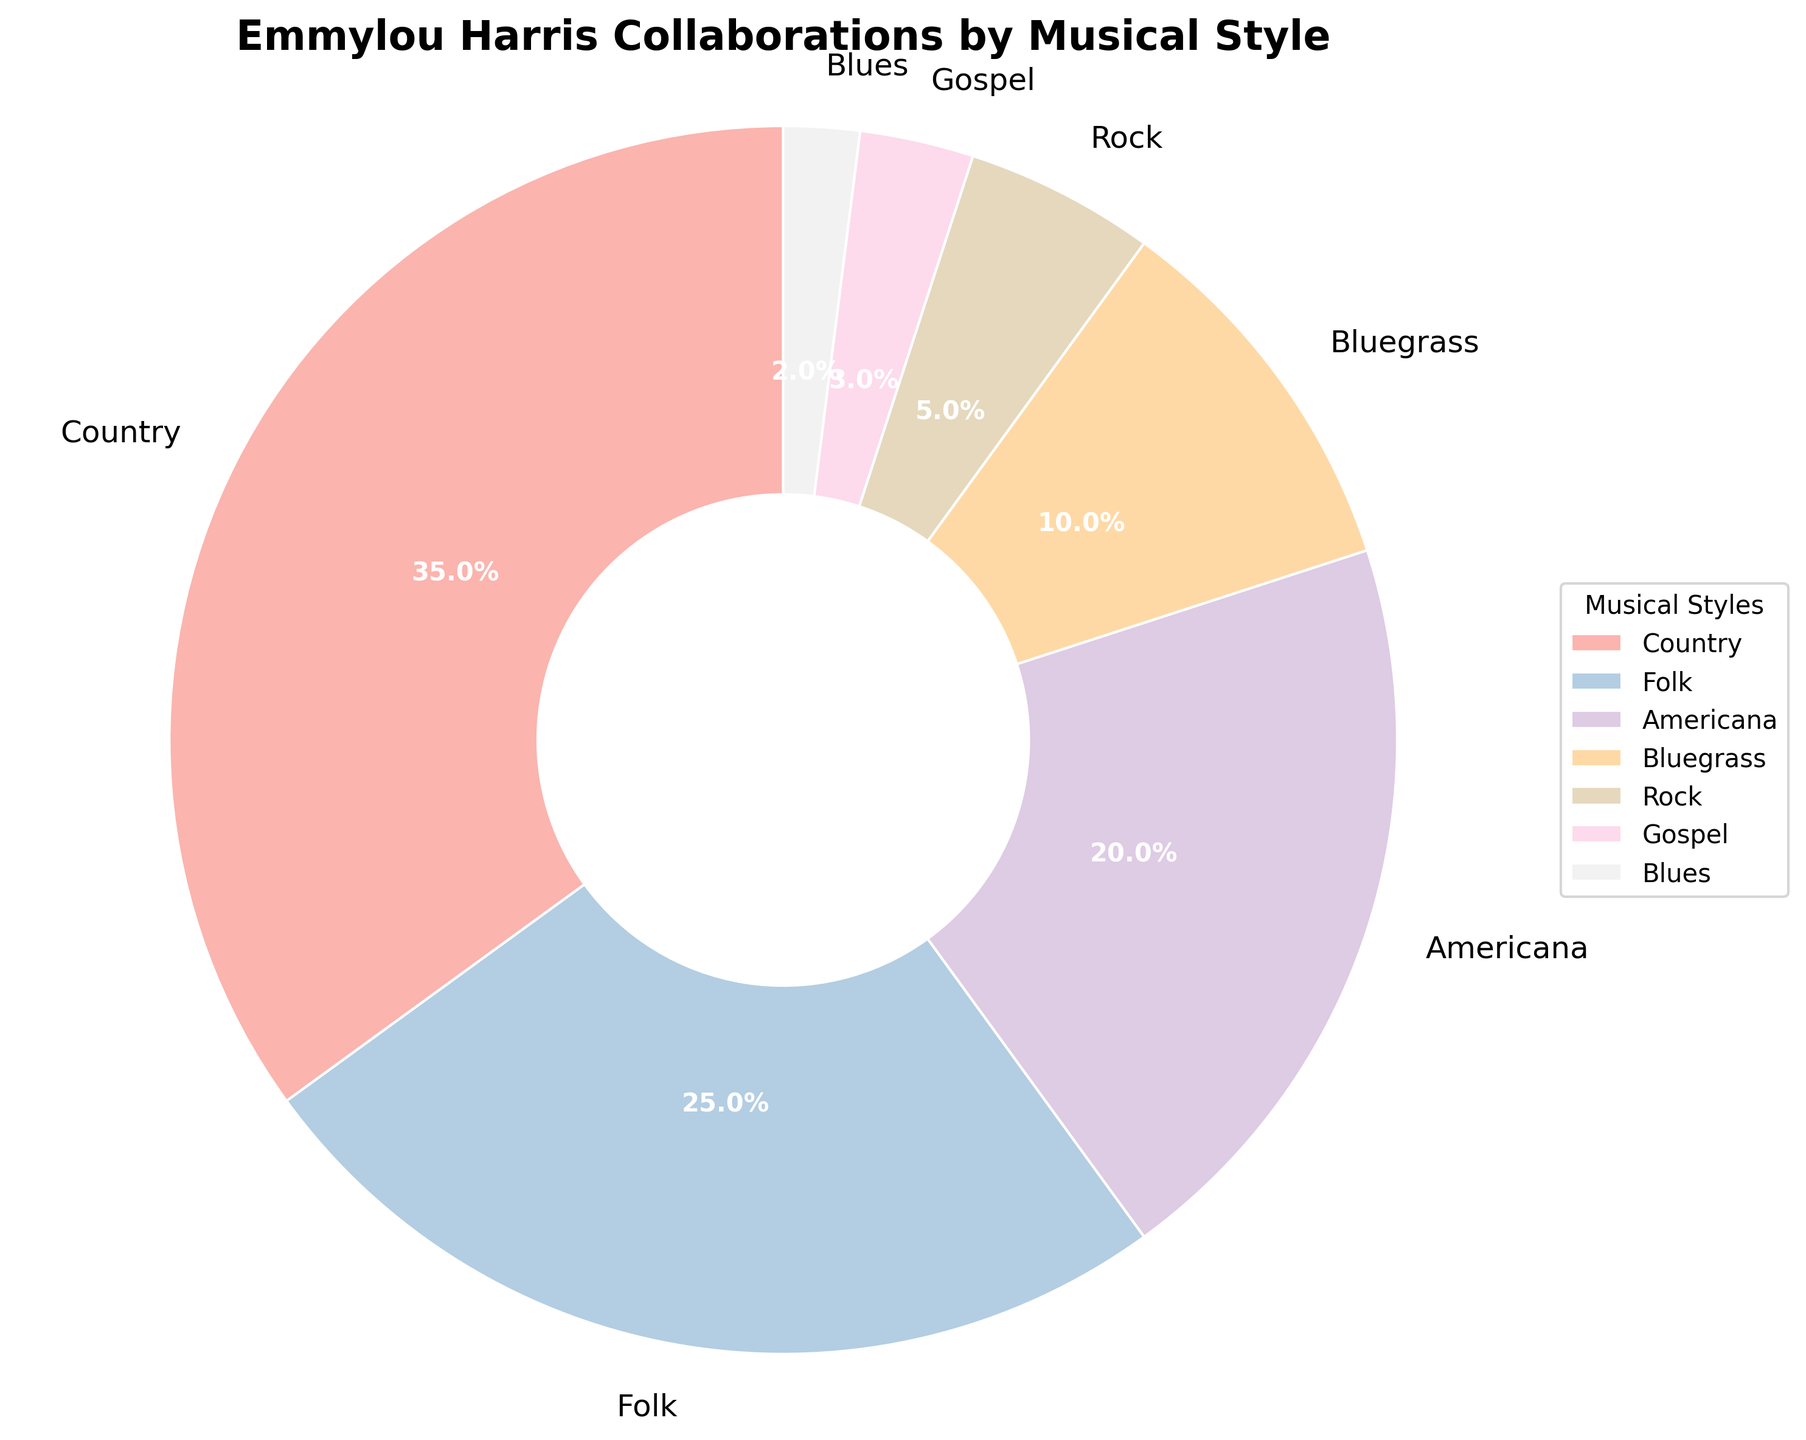What percentage of Emmylou Harris's collaborations fall within the Americana genre? The pie chart segment labeled "Americana" represents 20% of the collaborations. This value is directly visible on the pie chart as part of the label and the percentage annotation.
Answer: 20% How many musical styles make up less than 10% of Emmylou Harris's collaborations each? The pie chart shows segments for Rock (5%), Gospel (3%), and Blues (2%). Count each of these segments to find that three musical styles make up less than 10% each.
Answer: 3 Which musical style has the second highest percentage of collaborations with Emmylou Harris? The pie chart shows "Country" as the highest at 35%, and "Folk" as the second highest at 25%. Thus, "Folk" is the second highest.
Answer: Folk Are there more collaborations in Bluegrass and Gospel combined than in Americana alone? Bluegrass is 10%, and Gospel is 3%. Combined, they make 10% + 3% = 13%. Americana alone is 20%. Since 13% (combined) < 20% (Americana), there are not more collaborations in Bluegrass and Gospel combined than in Americana alone.
Answer: No What is the total percentage of collaborations combining the values for Folk, Gospel, and Blues genres? Summing up the percentages of Folk (25%), Gospel (3%), and Blues (2%) gives 25% + 3% + 2% = 30%.
Answer: 30% Which musical style segment has the smallest percentage, and what is it? The pie chart shows "Blues" with the smallest percentage at 2%. This is directly visible on the pie chart.
Answer: Blues, 2% How does the percentage of collaborations in Rock compare to that in Folk? The pie chart shows "Rock" at 5% and "Folk" at 25%. Since 5% < 25%, the percentage of collaborations in Rock is less than that in Folk.
Answer: Less Is there a musical style that constitutes exactly one-tenth of Emmylou Harris's collaborations? The pie chart shows that "Bluegrass" has a 10% segment, which is exactly one-tenth. This value is directly seen in the pie chart labels.
Answer: Yes, Bluegrass What is the range of collaboration percentages across all musical styles? The range is calculated by subtracting the smallest percentage (Blues, 2%) from the largest percentage (Country, 35%), resulting in 35% - 2% = 33%.
Answer: 33% 